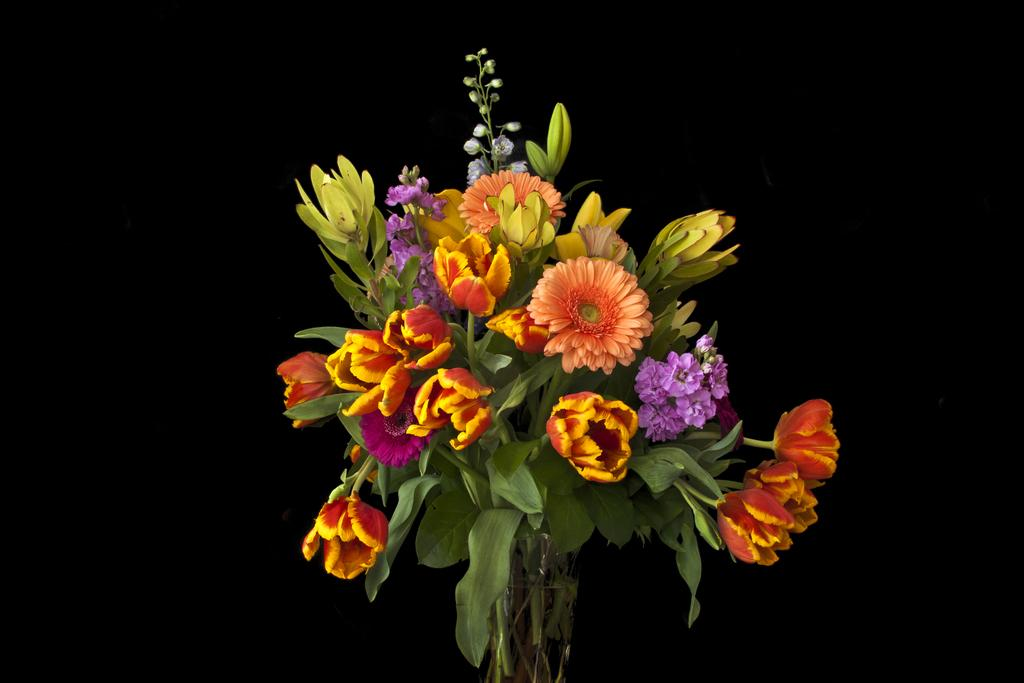What object is present in the image that holds flowers? There is a vase in the image that contains flowers. What can be found inside the vase? The vase contains flowers. What additional feature can be observed on the flowers? The flowers have leaves on their stems. What color is the background of the image? The background of the image is black. How many visitors are present in the image wearing a sweater? There are no visitors present in the image, and no one is wearing a sweater. What type of request can be seen being made in the image? There is no request visible in the image; it only features a vase with flowers and a black background. 